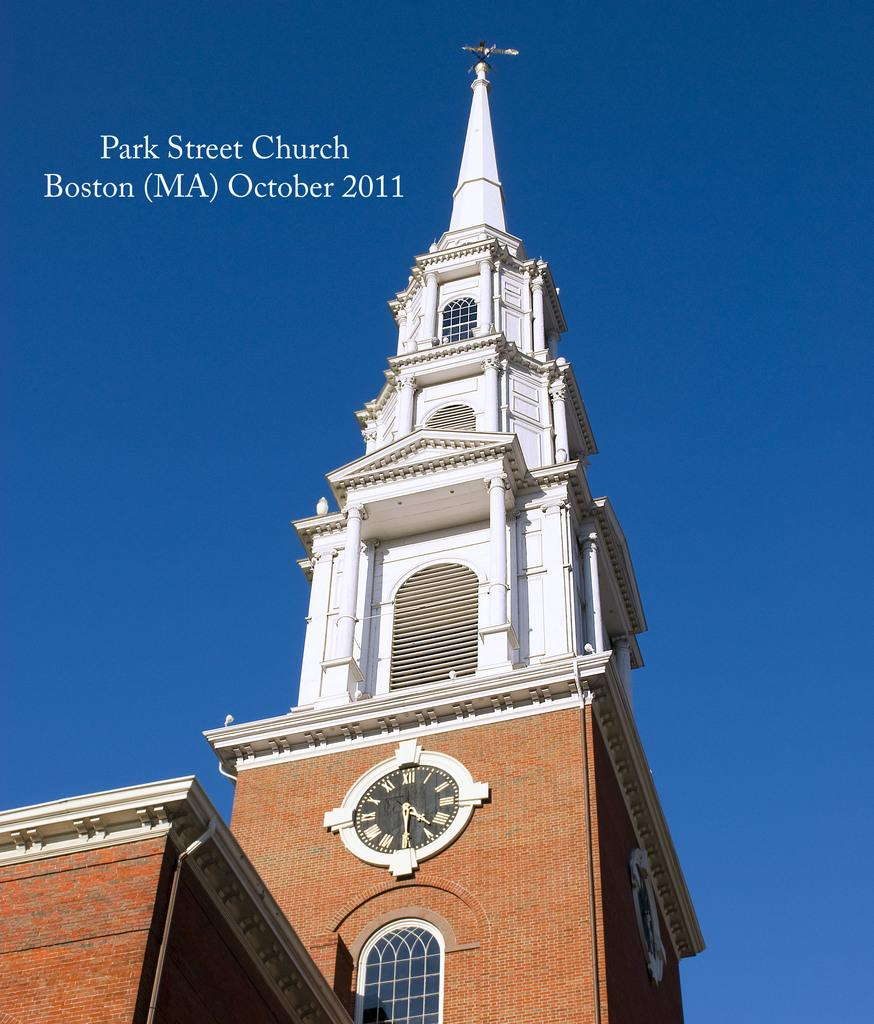Provide a one-sentence caption for the provided image. The historic Park Street Church steeple in Boston. 